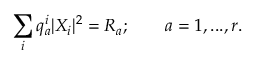Convert formula to latex. <formula><loc_0><loc_0><loc_500><loc_500>\sum _ { i } q _ { a } ^ { i } | X _ { i } | ^ { 2 } = R _ { a } ; \quad a = 1 , \dots , r .</formula> 